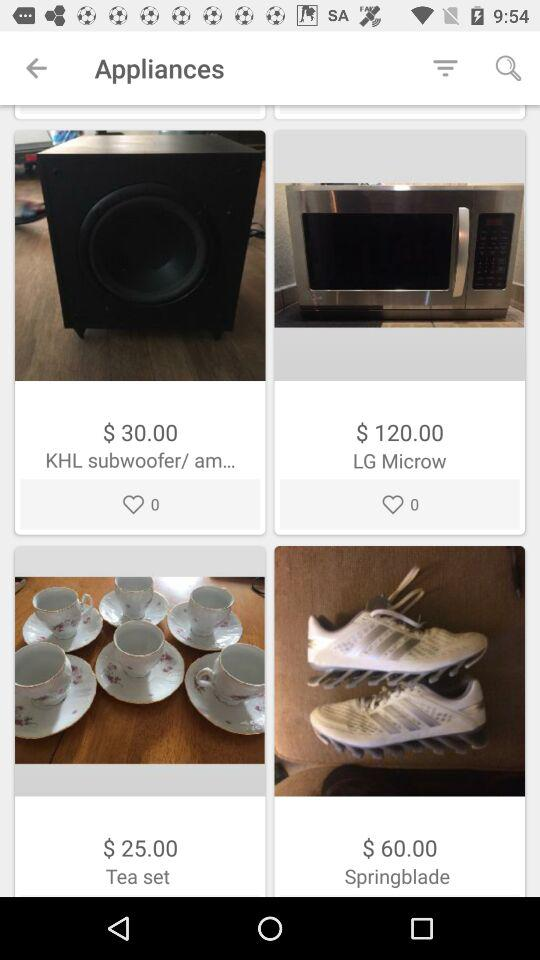What is the price of a KHL subwoofer/ am...? The price of a KHL subwoofer is $30.0. 